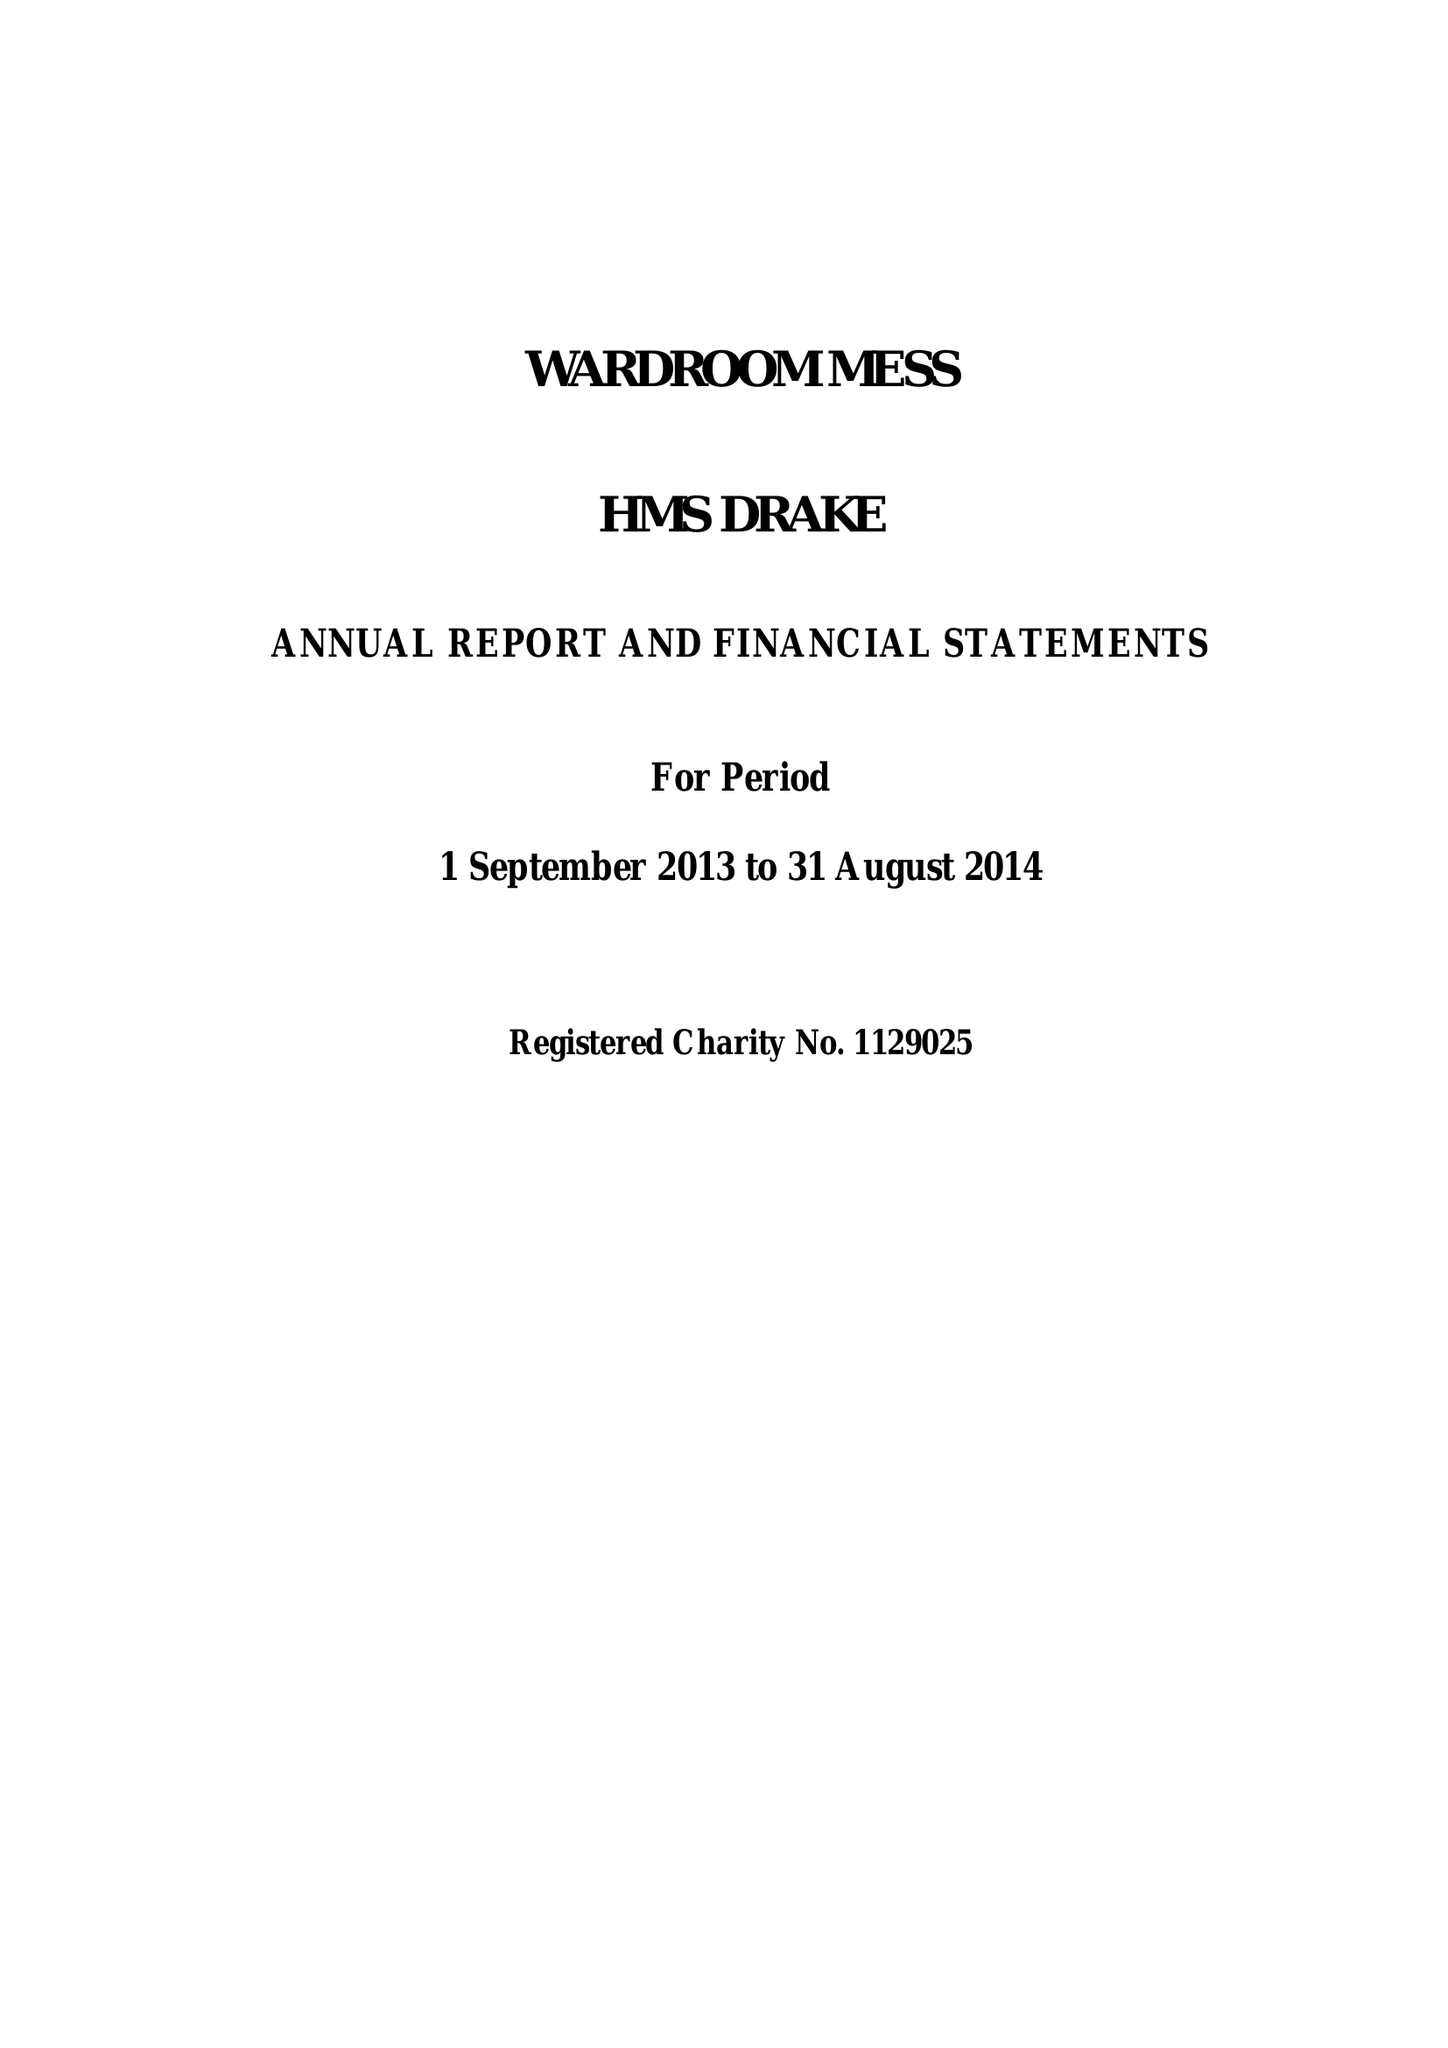What is the value for the charity_number?
Answer the question using a single word or phrase. 1129025 